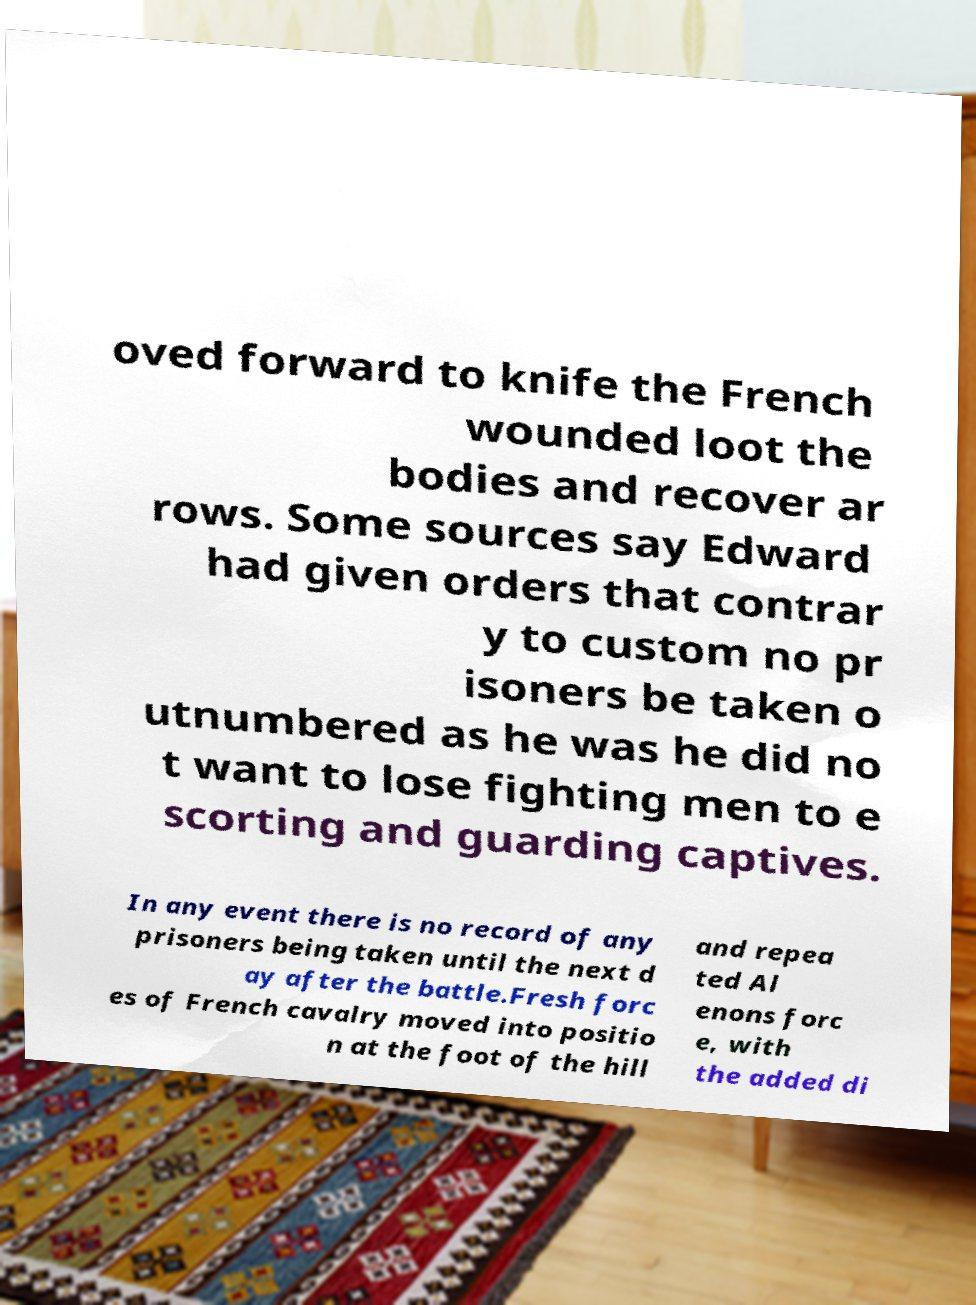Could you assist in decoding the text presented in this image and type it out clearly? oved forward to knife the French wounded loot the bodies and recover ar rows. Some sources say Edward had given orders that contrar y to custom no pr isoners be taken o utnumbered as he was he did no t want to lose fighting men to e scorting and guarding captives. In any event there is no record of any prisoners being taken until the next d ay after the battle.Fresh forc es of French cavalry moved into positio n at the foot of the hill and repea ted Al enons forc e, with the added di 